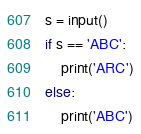<code> <loc_0><loc_0><loc_500><loc_500><_Python_>s = input()
if s == 'ABC':
    print('ARC')
else:
    print('ABC')
</code> 